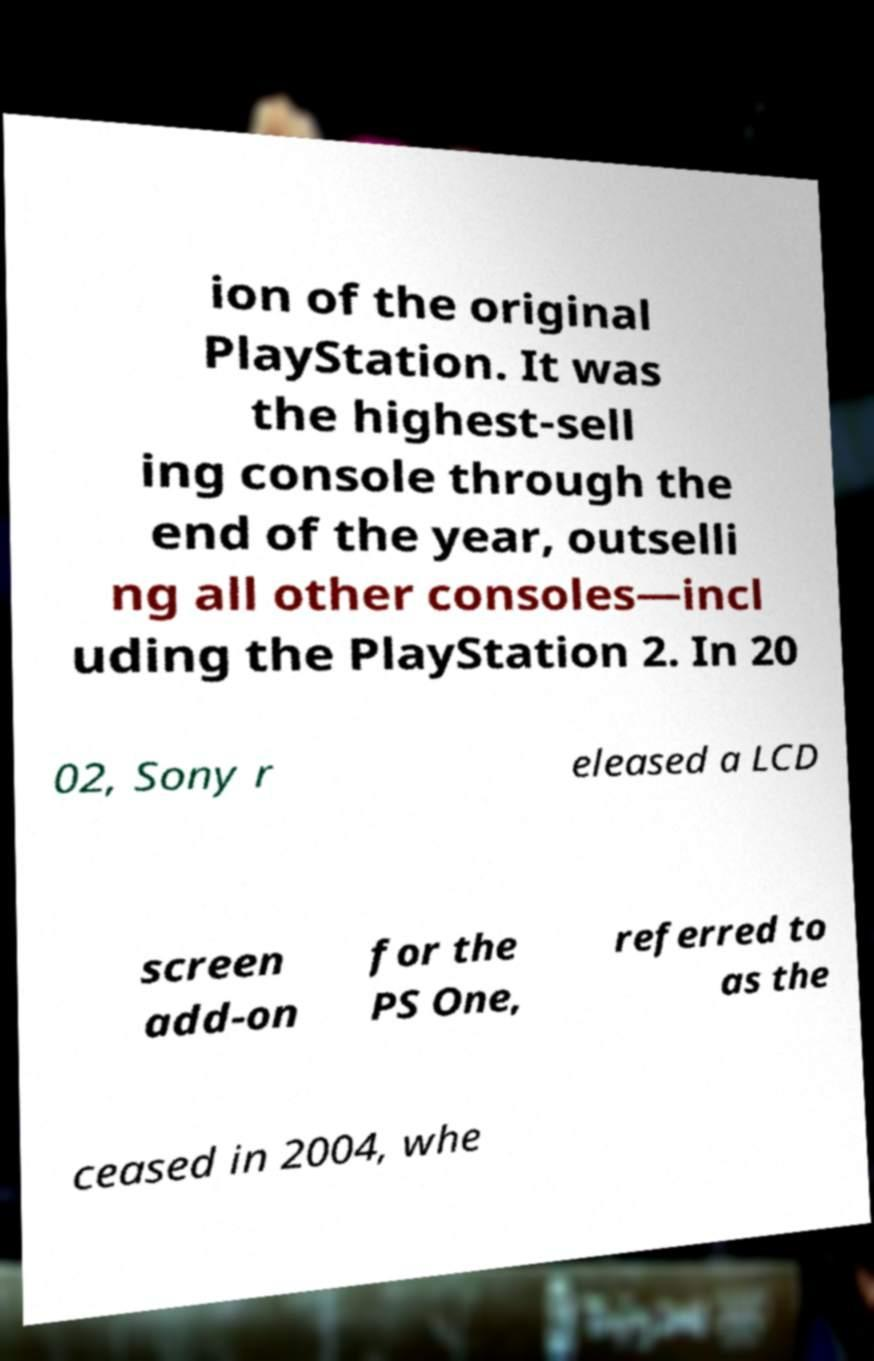I need the written content from this picture converted into text. Can you do that? ion of the original PlayStation. It was the highest-sell ing console through the end of the year, outselli ng all other consoles—incl uding the PlayStation 2. In 20 02, Sony r eleased a LCD screen add-on for the PS One, referred to as the ceased in 2004, whe 